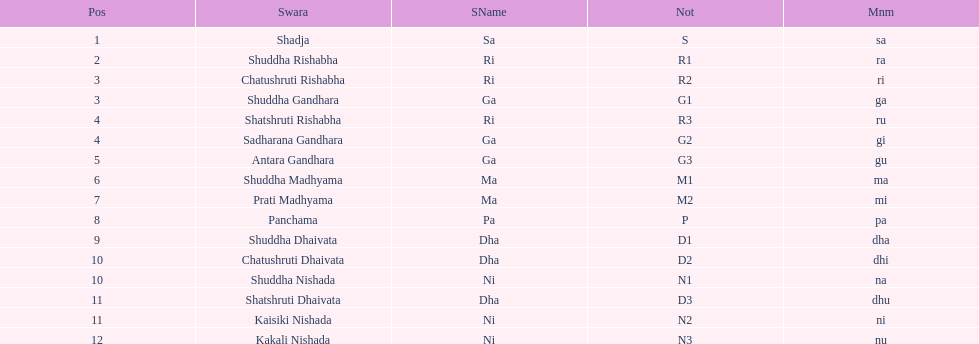List each pair of swaras that share the same position. Chatushruti Rishabha, Shuddha Gandhara, Shatshruti Rishabha, Sadharana Gandhara, Chatushruti Dhaivata, Shuddha Nishada, Shatshruti Dhaivata, Kaisiki Nishada. 